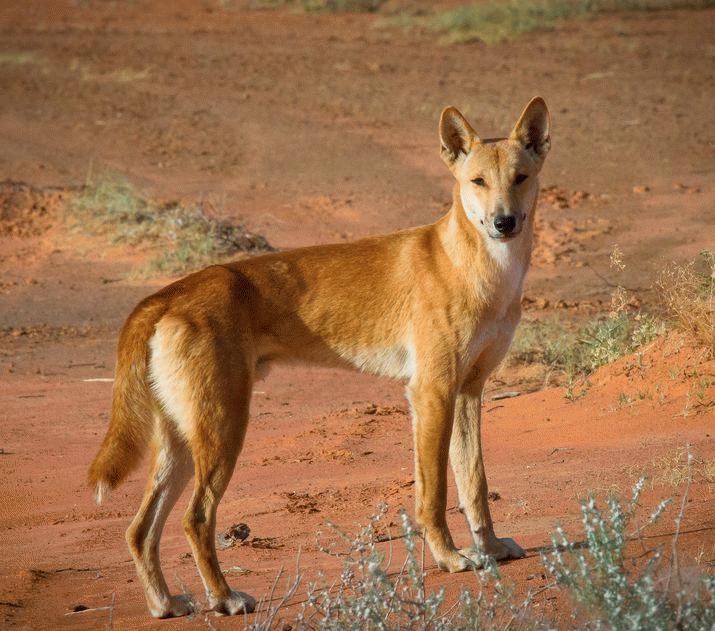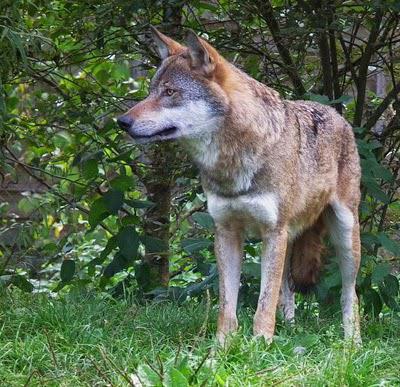The first image is the image on the left, the second image is the image on the right. Analyze the images presented: Is the assertion "There are exactly two animals in the image on the right." valid? Answer yes or no. No. 